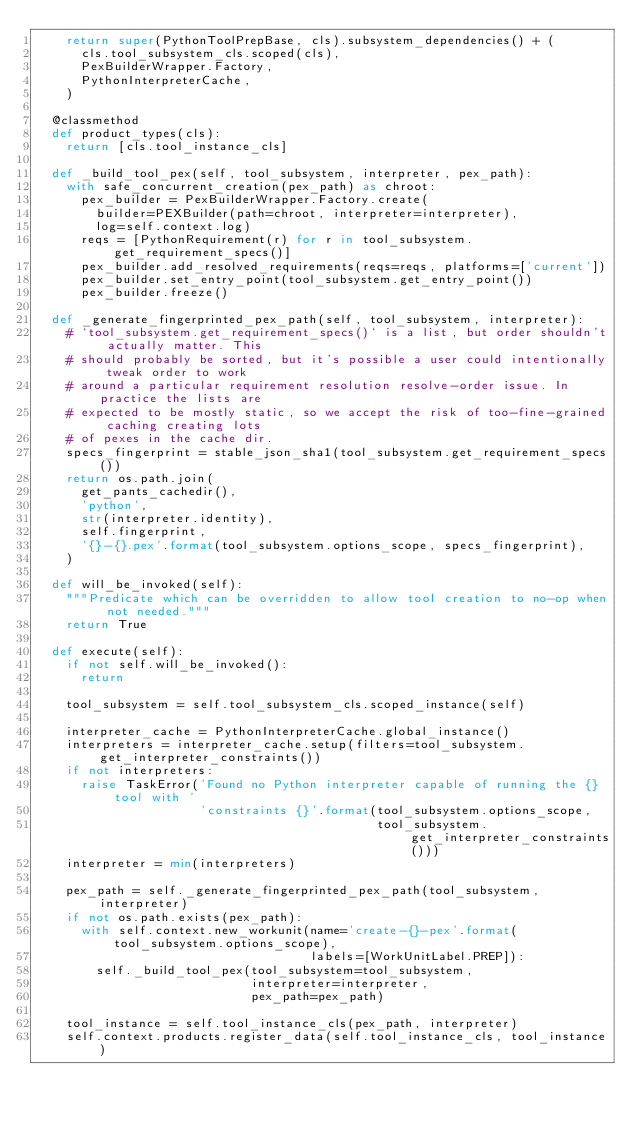<code> <loc_0><loc_0><loc_500><loc_500><_Python_>    return super(PythonToolPrepBase, cls).subsystem_dependencies() + (
      cls.tool_subsystem_cls.scoped(cls),
      PexBuilderWrapper.Factory,
      PythonInterpreterCache,
    )

  @classmethod
  def product_types(cls):
    return [cls.tool_instance_cls]

  def _build_tool_pex(self, tool_subsystem, interpreter, pex_path):
    with safe_concurrent_creation(pex_path) as chroot:
      pex_builder = PexBuilderWrapper.Factory.create(
        builder=PEXBuilder(path=chroot, interpreter=interpreter),
        log=self.context.log)
      reqs = [PythonRequirement(r) for r in tool_subsystem.get_requirement_specs()]
      pex_builder.add_resolved_requirements(reqs=reqs, platforms=['current'])
      pex_builder.set_entry_point(tool_subsystem.get_entry_point())
      pex_builder.freeze()

  def _generate_fingerprinted_pex_path(self, tool_subsystem, interpreter):
    # `tool_subsystem.get_requirement_specs()` is a list, but order shouldn't actually matter. This
    # should probably be sorted, but it's possible a user could intentionally tweak order to work
    # around a particular requirement resolution resolve-order issue. In practice the lists are
    # expected to be mostly static, so we accept the risk of too-fine-grained caching creating lots
    # of pexes in the cache dir.
    specs_fingerprint = stable_json_sha1(tool_subsystem.get_requirement_specs())
    return os.path.join(
      get_pants_cachedir(),
      'python',
      str(interpreter.identity),
      self.fingerprint,
      '{}-{}.pex'.format(tool_subsystem.options_scope, specs_fingerprint),
    )

  def will_be_invoked(self):
    """Predicate which can be overridden to allow tool creation to no-op when not needed."""
    return True

  def execute(self):
    if not self.will_be_invoked():
      return

    tool_subsystem = self.tool_subsystem_cls.scoped_instance(self)

    interpreter_cache = PythonInterpreterCache.global_instance()
    interpreters = interpreter_cache.setup(filters=tool_subsystem.get_interpreter_constraints())
    if not interpreters:
      raise TaskError('Found no Python interpreter capable of running the {} tool with '
                      'constraints {}'.format(tool_subsystem.options_scope,
                                              tool_subsystem.get_interpreter_constraints()))
    interpreter = min(interpreters)

    pex_path = self._generate_fingerprinted_pex_path(tool_subsystem, interpreter)
    if not os.path.exists(pex_path):
      with self.context.new_workunit(name='create-{}-pex'.format(tool_subsystem.options_scope),
                                     labels=[WorkUnitLabel.PREP]):
        self._build_tool_pex(tool_subsystem=tool_subsystem,
                             interpreter=interpreter,
                             pex_path=pex_path)

    tool_instance = self.tool_instance_cls(pex_path, interpreter)
    self.context.products.register_data(self.tool_instance_cls, tool_instance)
</code> 